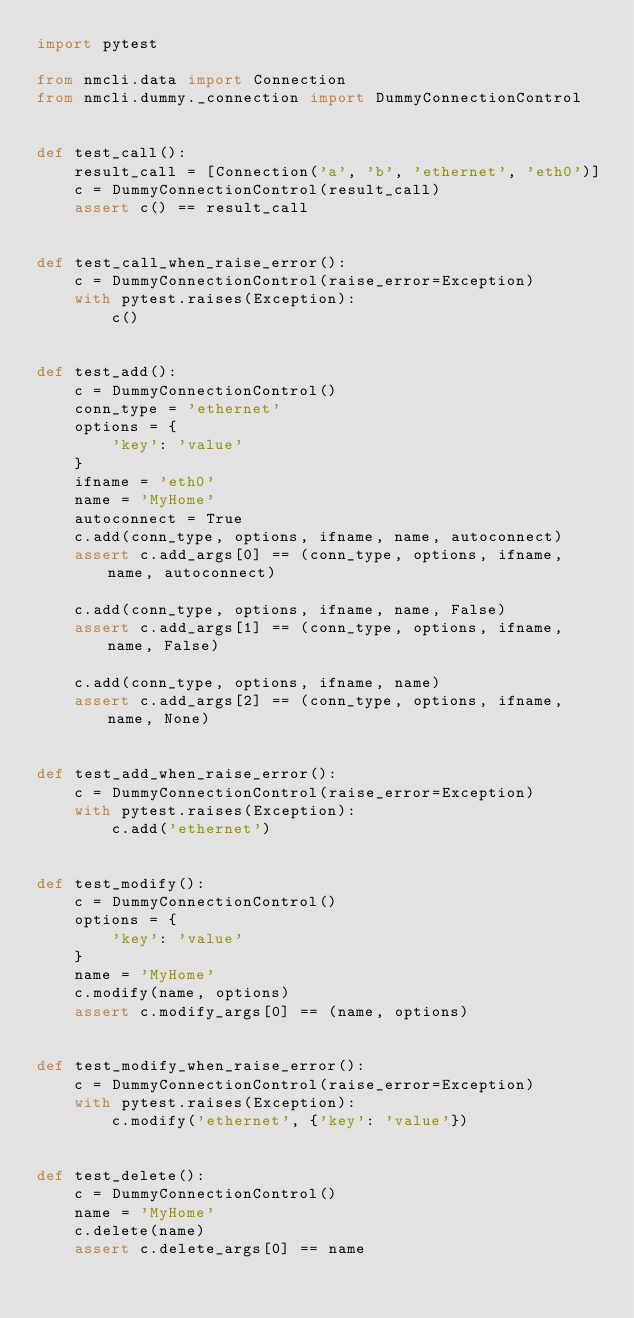Convert code to text. <code><loc_0><loc_0><loc_500><loc_500><_Python_>import pytest

from nmcli.data import Connection
from nmcli.dummy._connection import DummyConnectionControl


def test_call():
    result_call = [Connection('a', 'b', 'ethernet', 'eth0')]
    c = DummyConnectionControl(result_call)
    assert c() == result_call


def test_call_when_raise_error():
    c = DummyConnectionControl(raise_error=Exception)
    with pytest.raises(Exception):
        c()


def test_add():
    c = DummyConnectionControl()
    conn_type = 'ethernet'
    options = {
        'key': 'value'
    }
    ifname = 'eth0'
    name = 'MyHome'
    autoconnect = True
    c.add(conn_type, options, ifname, name, autoconnect)
    assert c.add_args[0] == (conn_type, options, ifname, name, autoconnect)

    c.add(conn_type, options, ifname, name, False)
    assert c.add_args[1] == (conn_type, options, ifname, name, False)

    c.add(conn_type, options, ifname, name)
    assert c.add_args[2] == (conn_type, options, ifname, name, None)


def test_add_when_raise_error():
    c = DummyConnectionControl(raise_error=Exception)
    with pytest.raises(Exception):
        c.add('ethernet')


def test_modify():
    c = DummyConnectionControl()
    options = {
        'key': 'value'
    }
    name = 'MyHome'
    c.modify(name, options)
    assert c.modify_args[0] == (name, options)


def test_modify_when_raise_error():
    c = DummyConnectionControl(raise_error=Exception)
    with pytest.raises(Exception):
        c.modify('ethernet', {'key': 'value'})


def test_delete():
    c = DummyConnectionControl()
    name = 'MyHome'
    c.delete(name)
    assert c.delete_args[0] == name

</code> 